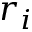Convert formula to latex. <formula><loc_0><loc_0><loc_500><loc_500>r _ { i }</formula> 